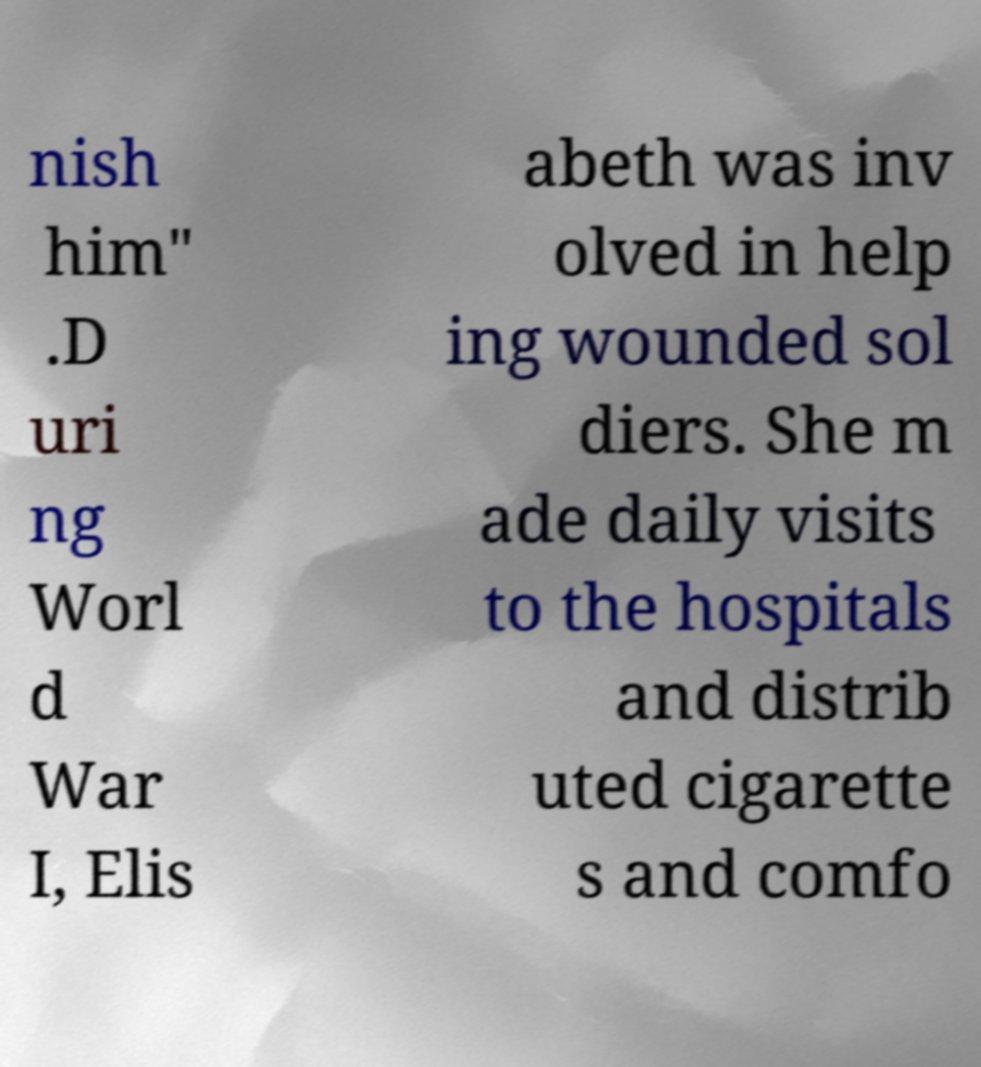Please read and relay the text visible in this image. What does it say? nish him" .D uri ng Worl d War I, Elis abeth was inv olved in help ing wounded sol diers. She m ade daily visits to the hospitals and distrib uted cigarette s and comfo 